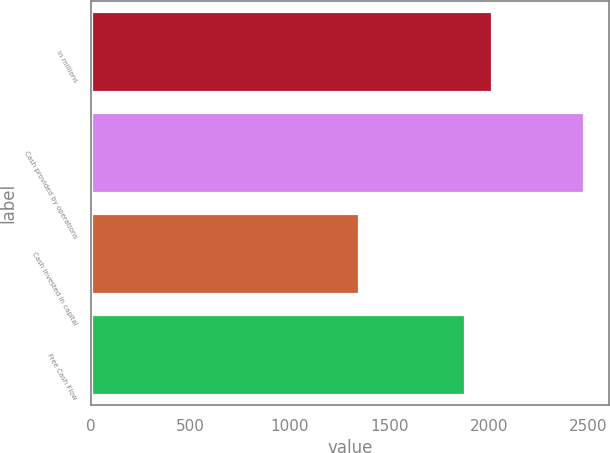Convert chart. <chart><loc_0><loc_0><loc_500><loc_500><bar_chart><fcel>In millions<fcel>Cash provided by operations<fcel>Cash invested in capital<fcel>Free Cash Flow<nl><fcel>2016<fcel>2478<fcel>1348<fcel>1880<nl></chart> 